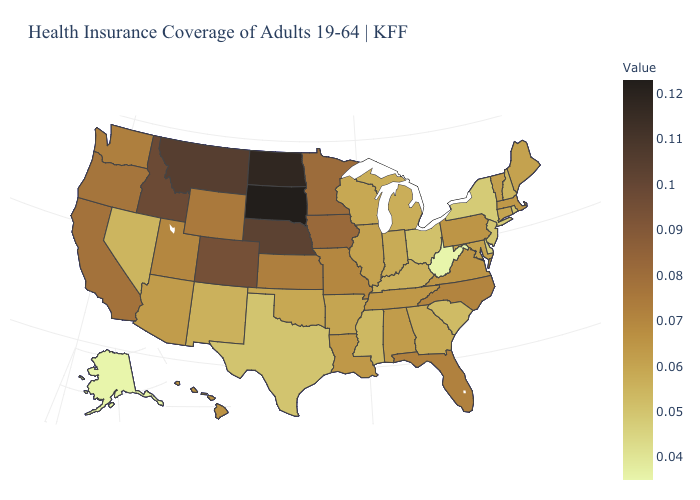Does South Dakota have the highest value in the USA?
Be succinct. Yes. Does the map have missing data?
Answer briefly. No. Which states have the lowest value in the USA?
Concise answer only. Alaska, West Virginia. Which states have the lowest value in the West?
Be succinct. Alaska. Does South Dakota have the highest value in the USA?
Answer briefly. Yes. Which states have the lowest value in the South?
Keep it brief. West Virginia. 